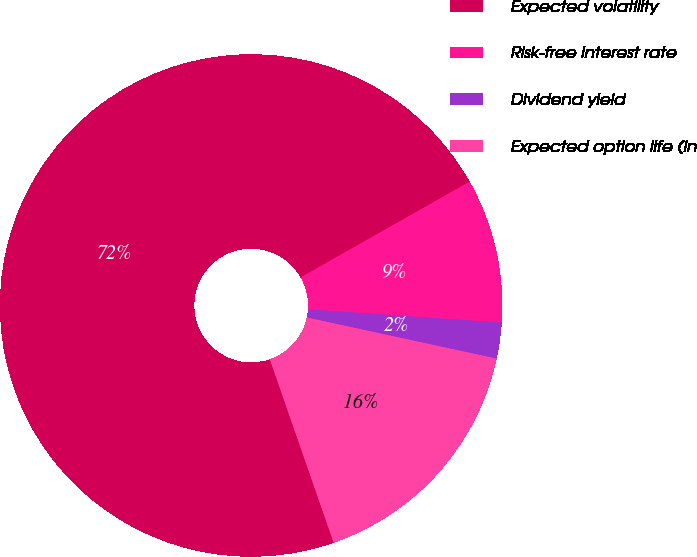Convert chart. <chart><loc_0><loc_0><loc_500><loc_500><pie_chart><fcel>Expected volatility<fcel>Risk-free interest rate<fcel>Dividend yield<fcel>Expected option life (in<nl><fcel>72.12%<fcel>9.29%<fcel>2.31%<fcel>16.27%<nl></chart> 